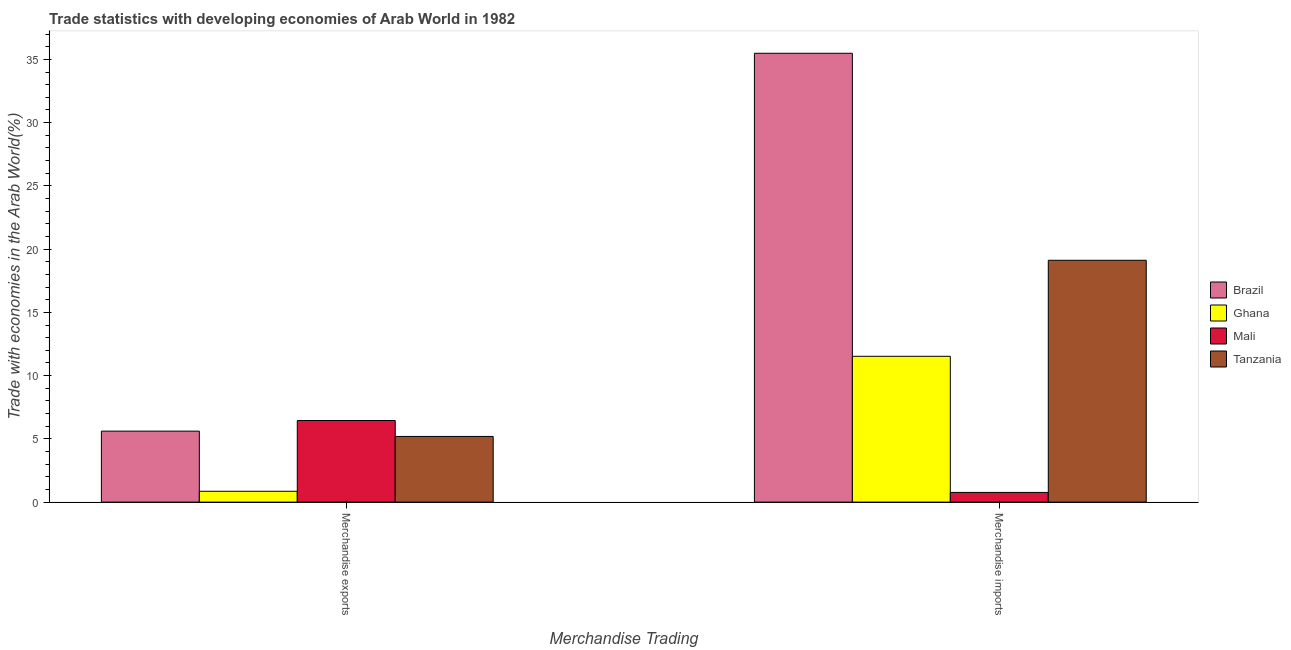Are the number of bars per tick equal to the number of legend labels?
Offer a very short reply. Yes. What is the label of the 2nd group of bars from the left?
Offer a terse response. Merchandise imports. What is the merchandise exports in Ghana?
Keep it short and to the point. 0.86. Across all countries, what is the maximum merchandise imports?
Provide a succinct answer. 35.48. Across all countries, what is the minimum merchandise exports?
Your answer should be very brief. 0.86. In which country was the merchandise exports maximum?
Your answer should be compact. Mali. What is the total merchandise imports in the graph?
Make the answer very short. 66.9. What is the difference between the merchandise imports in Tanzania and that in Brazil?
Provide a succinct answer. -16.37. What is the difference between the merchandise imports in Mali and the merchandise exports in Brazil?
Offer a terse response. -4.84. What is the average merchandise imports per country?
Your response must be concise. 16.73. What is the difference between the merchandise imports and merchandise exports in Brazil?
Your answer should be compact. 29.87. What is the ratio of the merchandise exports in Brazil to that in Tanzania?
Your response must be concise. 1.08. Is the merchandise exports in Brazil less than that in Mali?
Make the answer very short. Yes. What does the 4th bar from the left in Merchandise imports represents?
Offer a terse response. Tanzania. What does the 3rd bar from the right in Merchandise imports represents?
Offer a terse response. Ghana. How many bars are there?
Keep it short and to the point. 8. How many countries are there in the graph?
Your answer should be very brief. 4. What is the difference between two consecutive major ticks on the Y-axis?
Your response must be concise. 5. Are the values on the major ticks of Y-axis written in scientific E-notation?
Keep it short and to the point. No. How many legend labels are there?
Offer a terse response. 4. What is the title of the graph?
Give a very brief answer. Trade statistics with developing economies of Arab World in 1982. What is the label or title of the X-axis?
Keep it short and to the point. Merchandise Trading. What is the label or title of the Y-axis?
Ensure brevity in your answer.  Trade with economies in the Arab World(%). What is the Trade with economies in the Arab World(%) in Brazil in Merchandise exports?
Offer a terse response. 5.61. What is the Trade with economies in the Arab World(%) in Ghana in Merchandise exports?
Offer a very short reply. 0.86. What is the Trade with economies in the Arab World(%) of Mali in Merchandise exports?
Your answer should be very brief. 6.45. What is the Trade with economies in the Arab World(%) of Tanzania in Merchandise exports?
Ensure brevity in your answer.  5.19. What is the Trade with economies in the Arab World(%) of Brazil in Merchandise imports?
Make the answer very short. 35.48. What is the Trade with economies in the Arab World(%) in Ghana in Merchandise imports?
Your answer should be very brief. 11.53. What is the Trade with economies in the Arab World(%) of Mali in Merchandise imports?
Keep it short and to the point. 0.77. What is the Trade with economies in the Arab World(%) of Tanzania in Merchandise imports?
Your answer should be very brief. 19.12. Across all Merchandise Trading, what is the maximum Trade with economies in the Arab World(%) of Brazil?
Ensure brevity in your answer.  35.48. Across all Merchandise Trading, what is the maximum Trade with economies in the Arab World(%) of Ghana?
Offer a terse response. 11.53. Across all Merchandise Trading, what is the maximum Trade with economies in the Arab World(%) in Mali?
Offer a very short reply. 6.45. Across all Merchandise Trading, what is the maximum Trade with economies in the Arab World(%) in Tanzania?
Give a very brief answer. 19.12. Across all Merchandise Trading, what is the minimum Trade with economies in the Arab World(%) in Brazil?
Give a very brief answer. 5.61. Across all Merchandise Trading, what is the minimum Trade with economies in the Arab World(%) of Ghana?
Make the answer very short. 0.86. Across all Merchandise Trading, what is the minimum Trade with economies in the Arab World(%) in Mali?
Offer a terse response. 0.77. Across all Merchandise Trading, what is the minimum Trade with economies in the Arab World(%) in Tanzania?
Keep it short and to the point. 5.19. What is the total Trade with economies in the Arab World(%) in Brazil in the graph?
Offer a terse response. 41.1. What is the total Trade with economies in the Arab World(%) of Ghana in the graph?
Provide a short and direct response. 12.39. What is the total Trade with economies in the Arab World(%) of Mali in the graph?
Keep it short and to the point. 7.22. What is the total Trade with economies in the Arab World(%) of Tanzania in the graph?
Your answer should be compact. 24.31. What is the difference between the Trade with economies in the Arab World(%) in Brazil in Merchandise exports and that in Merchandise imports?
Give a very brief answer. -29.87. What is the difference between the Trade with economies in the Arab World(%) of Ghana in Merchandise exports and that in Merchandise imports?
Keep it short and to the point. -10.67. What is the difference between the Trade with economies in the Arab World(%) of Mali in Merchandise exports and that in Merchandise imports?
Your answer should be compact. 5.69. What is the difference between the Trade with economies in the Arab World(%) of Tanzania in Merchandise exports and that in Merchandise imports?
Offer a very short reply. -13.93. What is the difference between the Trade with economies in the Arab World(%) in Brazil in Merchandise exports and the Trade with economies in the Arab World(%) in Ghana in Merchandise imports?
Offer a very short reply. -5.92. What is the difference between the Trade with economies in the Arab World(%) of Brazil in Merchandise exports and the Trade with economies in the Arab World(%) of Mali in Merchandise imports?
Make the answer very short. 4.84. What is the difference between the Trade with economies in the Arab World(%) of Brazil in Merchandise exports and the Trade with economies in the Arab World(%) of Tanzania in Merchandise imports?
Ensure brevity in your answer.  -13.51. What is the difference between the Trade with economies in the Arab World(%) in Ghana in Merchandise exports and the Trade with economies in the Arab World(%) in Mali in Merchandise imports?
Your answer should be compact. 0.09. What is the difference between the Trade with economies in the Arab World(%) of Ghana in Merchandise exports and the Trade with economies in the Arab World(%) of Tanzania in Merchandise imports?
Offer a terse response. -18.26. What is the difference between the Trade with economies in the Arab World(%) in Mali in Merchandise exports and the Trade with economies in the Arab World(%) in Tanzania in Merchandise imports?
Ensure brevity in your answer.  -12.67. What is the average Trade with economies in the Arab World(%) of Brazil per Merchandise Trading?
Make the answer very short. 20.55. What is the average Trade with economies in the Arab World(%) in Ghana per Merchandise Trading?
Provide a succinct answer. 6.19. What is the average Trade with economies in the Arab World(%) of Mali per Merchandise Trading?
Offer a terse response. 3.61. What is the average Trade with economies in the Arab World(%) of Tanzania per Merchandise Trading?
Ensure brevity in your answer.  12.16. What is the difference between the Trade with economies in the Arab World(%) in Brazil and Trade with economies in the Arab World(%) in Ghana in Merchandise exports?
Provide a succinct answer. 4.75. What is the difference between the Trade with economies in the Arab World(%) in Brazil and Trade with economies in the Arab World(%) in Mali in Merchandise exports?
Provide a succinct answer. -0.84. What is the difference between the Trade with economies in the Arab World(%) of Brazil and Trade with economies in the Arab World(%) of Tanzania in Merchandise exports?
Ensure brevity in your answer.  0.42. What is the difference between the Trade with economies in the Arab World(%) in Ghana and Trade with economies in the Arab World(%) in Mali in Merchandise exports?
Provide a short and direct response. -5.59. What is the difference between the Trade with economies in the Arab World(%) of Ghana and Trade with economies in the Arab World(%) of Tanzania in Merchandise exports?
Make the answer very short. -4.33. What is the difference between the Trade with economies in the Arab World(%) in Mali and Trade with economies in the Arab World(%) in Tanzania in Merchandise exports?
Keep it short and to the point. 1.26. What is the difference between the Trade with economies in the Arab World(%) of Brazil and Trade with economies in the Arab World(%) of Ghana in Merchandise imports?
Your answer should be very brief. 23.96. What is the difference between the Trade with economies in the Arab World(%) of Brazil and Trade with economies in the Arab World(%) of Mali in Merchandise imports?
Make the answer very short. 34.72. What is the difference between the Trade with economies in the Arab World(%) in Brazil and Trade with economies in the Arab World(%) in Tanzania in Merchandise imports?
Your answer should be compact. 16.37. What is the difference between the Trade with economies in the Arab World(%) in Ghana and Trade with economies in the Arab World(%) in Mali in Merchandise imports?
Offer a terse response. 10.76. What is the difference between the Trade with economies in the Arab World(%) of Ghana and Trade with economies in the Arab World(%) of Tanzania in Merchandise imports?
Ensure brevity in your answer.  -7.59. What is the difference between the Trade with economies in the Arab World(%) of Mali and Trade with economies in the Arab World(%) of Tanzania in Merchandise imports?
Offer a terse response. -18.35. What is the ratio of the Trade with economies in the Arab World(%) of Brazil in Merchandise exports to that in Merchandise imports?
Keep it short and to the point. 0.16. What is the ratio of the Trade with economies in the Arab World(%) in Ghana in Merchandise exports to that in Merchandise imports?
Ensure brevity in your answer.  0.07. What is the ratio of the Trade with economies in the Arab World(%) of Mali in Merchandise exports to that in Merchandise imports?
Make the answer very short. 8.41. What is the ratio of the Trade with economies in the Arab World(%) in Tanzania in Merchandise exports to that in Merchandise imports?
Make the answer very short. 0.27. What is the difference between the highest and the second highest Trade with economies in the Arab World(%) in Brazil?
Ensure brevity in your answer.  29.87. What is the difference between the highest and the second highest Trade with economies in the Arab World(%) of Ghana?
Give a very brief answer. 10.67. What is the difference between the highest and the second highest Trade with economies in the Arab World(%) in Mali?
Offer a terse response. 5.69. What is the difference between the highest and the second highest Trade with economies in the Arab World(%) of Tanzania?
Provide a succinct answer. 13.93. What is the difference between the highest and the lowest Trade with economies in the Arab World(%) of Brazil?
Keep it short and to the point. 29.87. What is the difference between the highest and the lowest Trade with economies in the Arab World(%) in Ghana?
Your response must be concise. 10.67. What is the difference between the highest and the lowest Trade with economies in the Arab World(%) in Mali?
Offer a terse response. 5.69. What is the difference between the highest and the lowest Trade with economies in the Arab World(%) of Tanzania?
Make the answer very short. 13.93. 